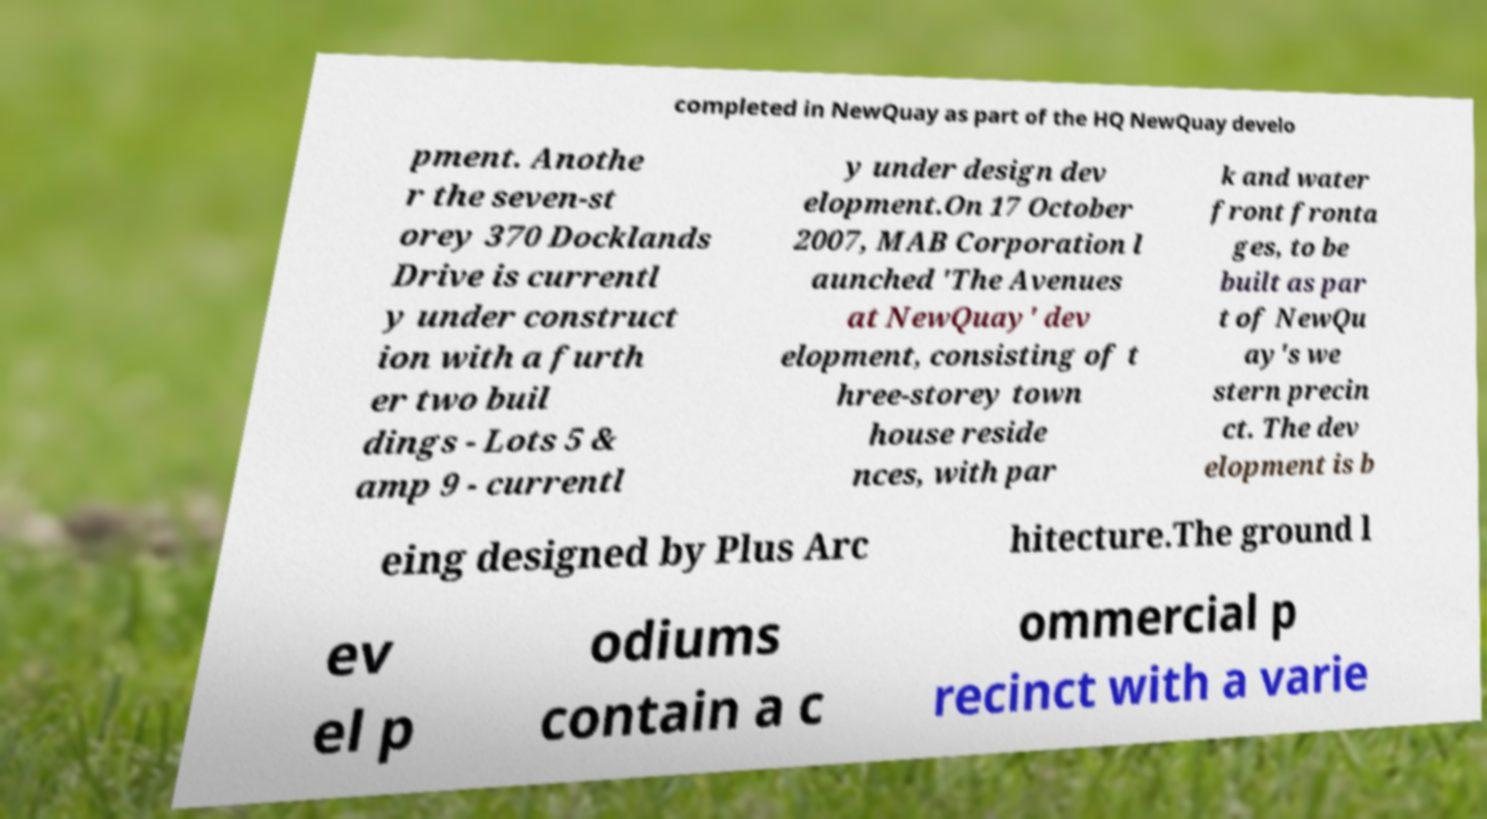Could you assist in decoding the text presented in this image and type it out clearly? completed in NewQuay as part of the HQ NewQuay develo pment. Anothe r the seven-st orey 370 Docklands Drive is currentl y under construct ion with a furth er two buil dings - Lots 5 & amp 9 - currentl y under design dev elopment.On 17 October 2007, MAB Corporation l aunched 'The Avenues at NewQuay' dev elopment, consisting of t hree-storey town house reside nces, with par k and water front fronta ges, to be built as par t of NewQu ay's we stern precin ct. The dev elopment is b eing designed by Plus Arc hitecture.The ground l ev el p odiums contain a c ommercial p recinct with a varie 